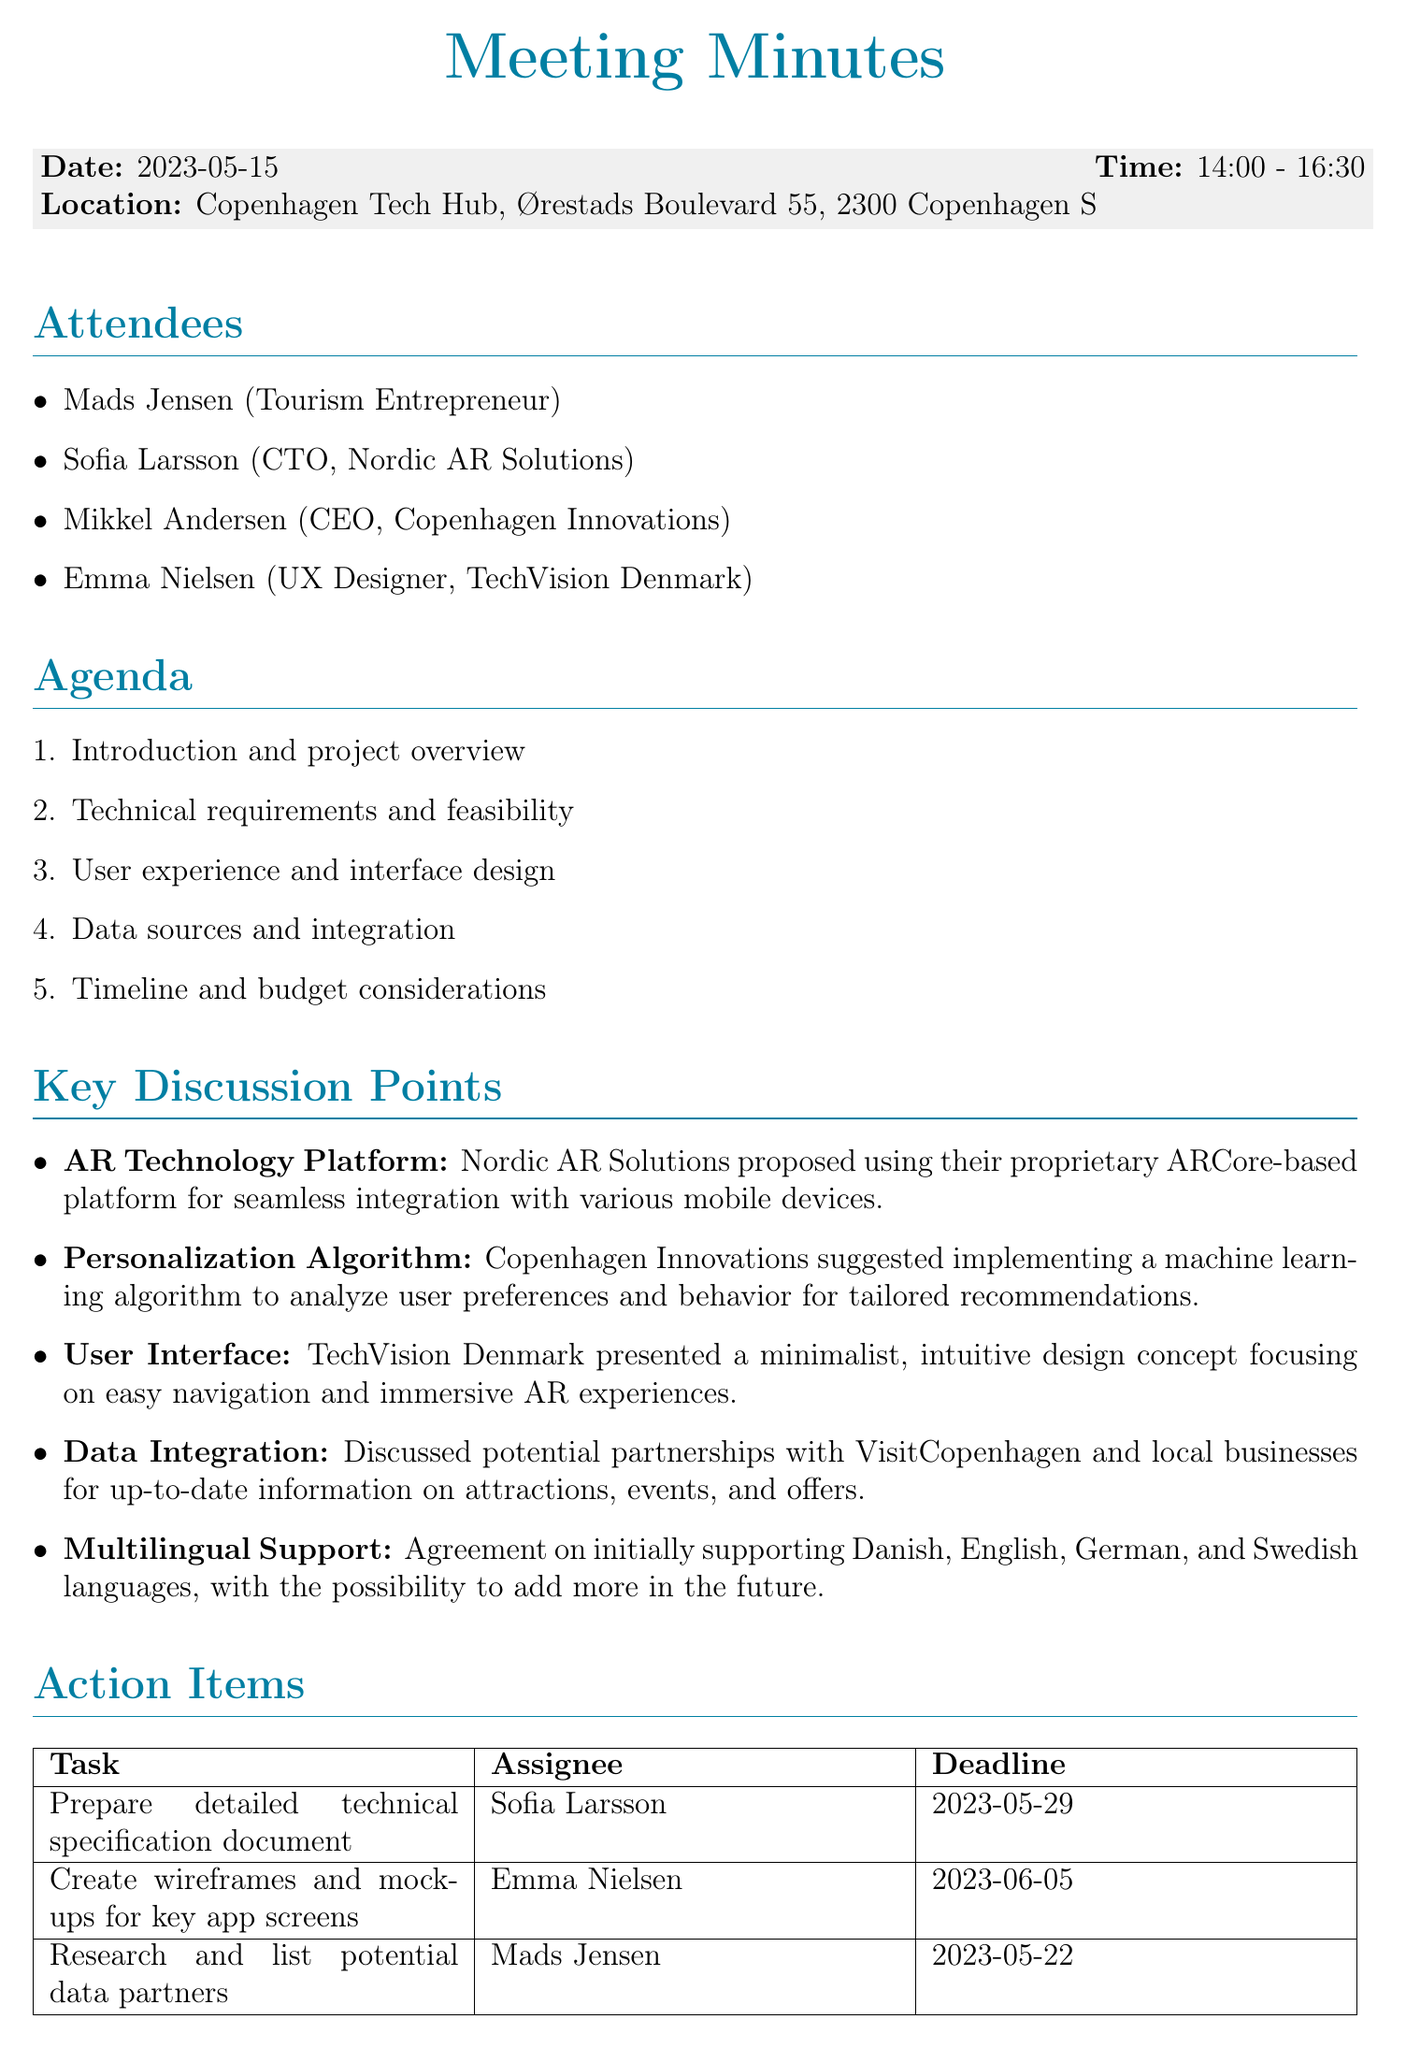What was the date of the meeting? The date of the meeting is specifically mentioned in the document header.
Answer: 2023-05-15 Who is the CTO of Nordic AR Solutions? The document lists attendees, including roles, making it easy to find this information.
Answer: Sofia Larsson What is the task assigned to Mads Jensen? The action items section details the assigned tasks and their respective assignees.
Answer: Research and list potential data partners When is the next meeting scheduled? The next meeting details are provided at the end of the document.
Answer: 2023-06-12 Which platform did Nordic AR Solutions propose for the AR app? The key discussion points include the proposed technology platform in the context of the app development.
Answer: ARCore-based platform What languages will the app initially support? The multilingual support section specifies which languages are planned for initial support.
Answer: Danish, English, German, and Swedish What is the deadline for Emma Nielsen's task? The deadlines for action items are outlined in the tabular section.
Answer: 2023-06-05 What type of design concept did TechVision Denmark present? The user interface discussion point outlines the design concept proposed during the meeting.
Answer: Minimalist, intuitive design concept 